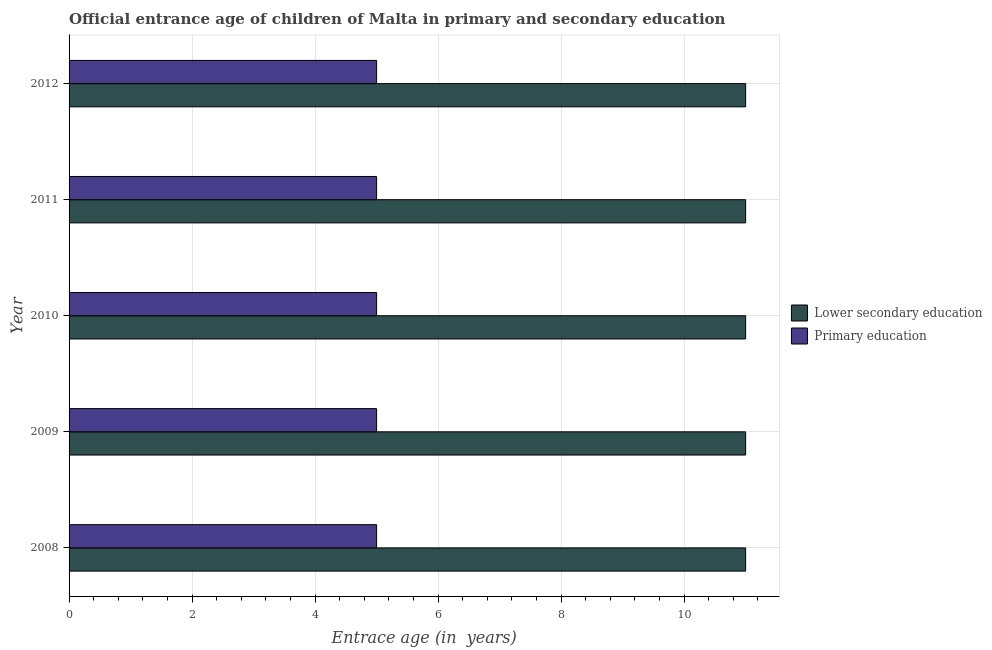How many groups of bars are there?
Provide a succinct answer. 5. How many bars are there on the 1st tick from the top?
Make the answer very short. 2. What is the label of the 4th group of bars from the top?
Your response must be concise. 2009. In how many cases, is the number of bars for a given year not equal to the number of legend labels?
Provide a short and direct response. 0. What is the entrance age of chiildren in primary education in 2012?
Offer a terse response. 5. Across all years, what is the maximum entrance age of chiildren in primary education?
Give a very brief answer. 5. Across all years, what is the minimum entrance age of chiildren in primary education?
Make the answer very short. 5. In which year was the entrance age of chiildren in primary education maximum?
Ensure brevity in your answer.  2008. In which year was the entrance age of children in lower secondary education minimum?
Give a very brief answer. 2008. What is the total entrance age of chiildren in primary education in the graph?
Offer a terse response. 25. What is the difference between the entrance age of children in lower secondary education in 2008 and that in 2010?
Offer a terse response. 0. What is the average entrance age of chiildren in primary education per year?
Your response must be concise. 5. What is the difference between the highest and the second highest entrance age of chiildren in primary education?
Provide a short and direct response. 0. In how many years, is the entrance age of chiildren in primary education greater than the average entrance age of chiildren in primary education taken over all years?
Keep it short and to the point. 0. Is the sum of the entrance age of chiildren in primary education in 2008 and 2012 greater than the maximum entrance age of children in lower secondary education across all years?
Your response must be concise. No. What does the 1st bar from the top in 2009 represents?
Make the answer very short. Primary education. What does the 1st bar from the bottom in 2009 represents?
Give a very brief answer. Lower secondary education. Are the values on the major ticks of X-axis written in scientific E-notation?
Offer a terse response. No. Does the graph contain any zero values?
Keep it short and to the point. No. Does the graph contain grids?
Offer a terse response. Yes. What is the title of the graph?
Offer a very short reply. Official entrance age of children of Malta in primary and secondary education. What is the label or title of the X-axis?
Your answer should be very brief. Entrace age (in  years). What is the label or title of the Y-axis?
Ensure brevity in your answer.  Year. What is the Entrace age (in  years) in Lower secondary education in 2008?
Provide a succinct answer. 11. What is the Entrace age (in  years) in Lower secondary education in 2010?
Your answer should be very brief. 11. What is the Entrace age (in  years) of Lower secondary education in 2011?
Your answer should be very brief. 11. What is the Entrace age (in  years) in Primary education in 2011?
Make the answer very short. 5. What is the Entrace age (in  years) in Lower secondary education in 2012?
Provide a short and direct response. 11. What is the Entrace age (in  years) in Primary education in 2012?
Your response must be concise. 5. Across all years, what is the maximum Entrace age (in  years) of Lower secondary education?
Your response must be concise. 11. What is the total Entrace age (in  years) in Primary education in the graph?
Make the answer very short. 25. What is the difference between the Entrace age (in  years) in Primary education in 2008 and that in 2009?
Make the answer very short. 0. What is the difference between the Entrace age (in  years) in Primary education in 2008 and that in 2010?
Provide a short and direct response. 0. What is the difference between the Entrace age (in  years) of Lower secondary education in 2008 and that in 2012?
Make the answer very short. 0. What is the difference between the Entrace age (in  years) of Primary education in 2009 and that in 2012?
Give a very brief answer. 0. What is the difference between the Entrace age (in  years) of Lower secondary education in 2010 and that in 2011?
Keep it short and to the point. 0. What is the difference between the Entrace age (in  years) in Lower secondary education in 2010 and that in 2012?
Provide a short and direct response. 0. What is the difference between the Entrace age (in  years) in Lower secondary education in 2008 and the Entrace age (in  years) in Primary education in 2010?
Your response must be concise. 6. What is the difference between the Entrace age (in  years) of Lower secondary education in 2009 and the Entrace age (in  years) of Primary education in 2011?
Provide a succinct answer. 6. What is the difference between the Entrace age (in  years) in Lower secondary education in 2010 and the Entrace age (in  years) in Primary education in 2011?
Offer a terse response. 6. What is the difference between the Entrace age (in  years) of Lower secondary education in 2011 and the Entrace age (in  years) of Primary education in 2012?
Make the answer very short. 6. What is the average Entrace age (in  years) of Lower secondary education per year?
Provide a succinct answer. 11. In the year 2009, what is the difference between the Entrace age (in  years) in Lower secondary education and Entrace age (in  years) in Primary education?
Offer a very short reply. 6. In the year 2011, what is the difference between the Entrace age (in  years) of Lower secondary education and Entrace age (in  years) of Primary education?
Make the answer very short. 6. In the year 2012, what is the difference between the Entrace age (in  years) of Lower secondary education and Entrace age (in  years) of Primary education?
Provide a succinct answer. 6. What is the ratio of the Entrace age (in  years) of Primary education in 2008 to that in 2009?
Your response must be concise. 1. What is the ratio of the Entrace age (in  years) of Lower secondary education in 2008 to that in 2012?
Your answer should be compact. 1. What is the ratio of the Entrace age (in  years) in Primary education in 2008 to that in 2012?
Make the answer very short. 1. What is the ratio of the Entrace age (in  years) in Primary education in 2009 to that in 2010?
Offer a terse response. 1. What is the ratio of the Entrace age (in  years) of Lower secondary education in 2010 to that in 2011?
Provide a short and direct response. 1. What is the ratio of the Entrace age (in  years) in Lower secondary education in 2011 to that in 2012?
Your answer should be very brief. 1. What is the ratio of the Entrace age (in  years) in Primary education in 2011 to that in 2012?
Give a very brief answer. 1. 